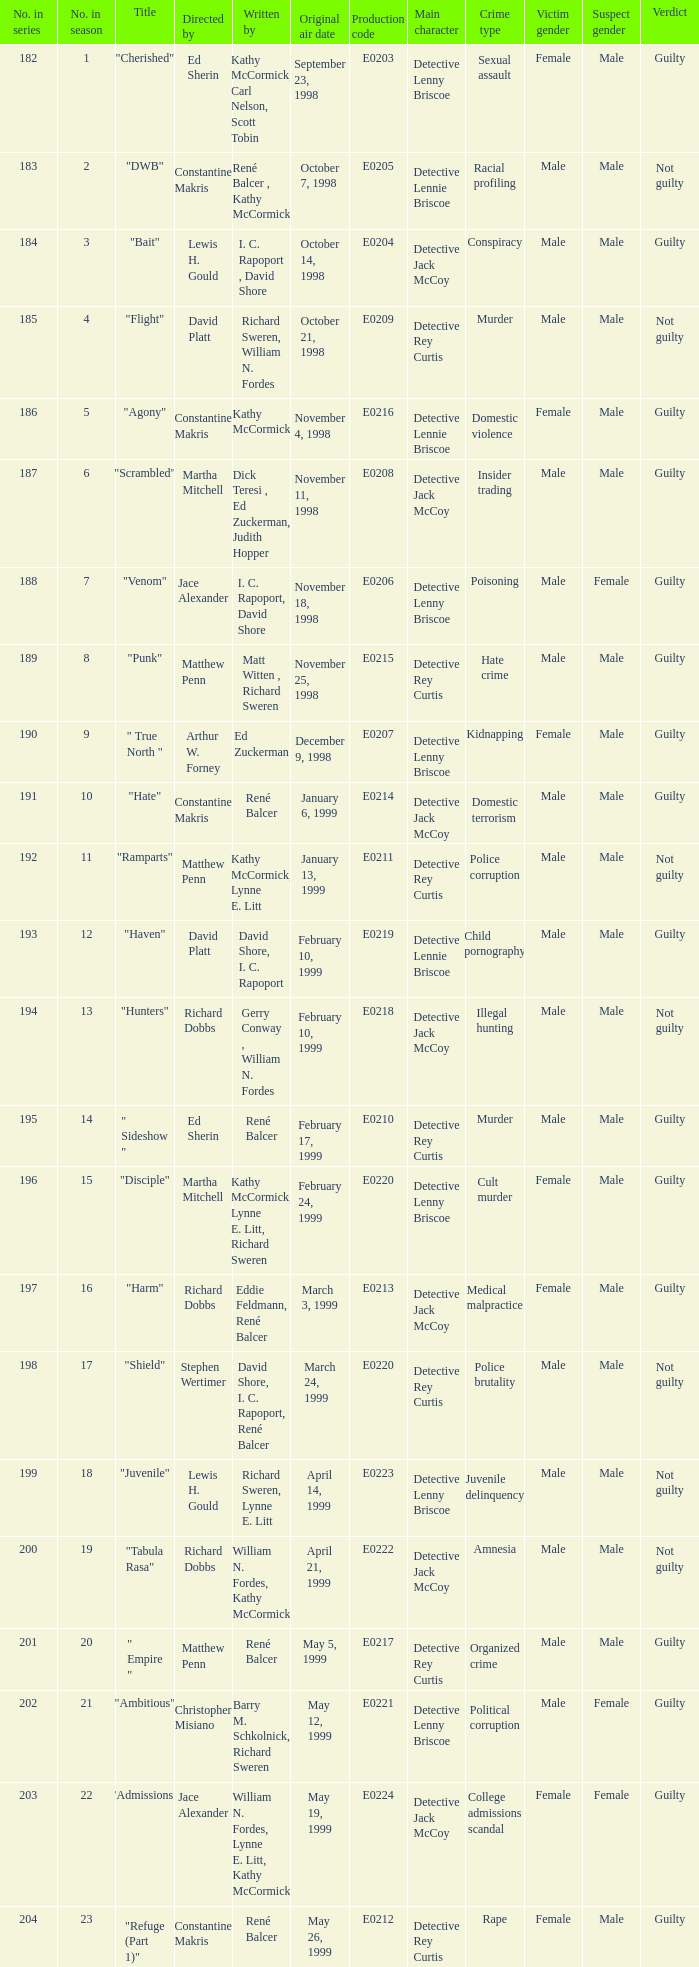The episode with the original air date January 6, 1999, has what production code? E0214. 